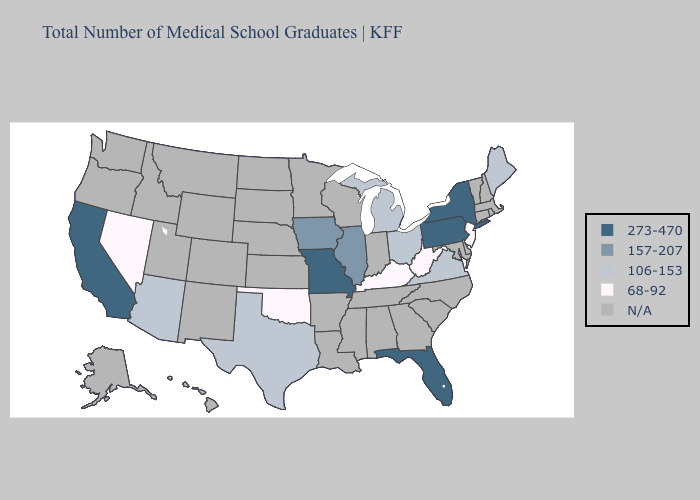What is the value of Florida?
Give a very brief answer. 273-470. Does New York have the highest value in the USA?
Keep it brief. Yes. Does California have the lowest value in the West?
Concise answer only. No. What is the lowest value in the South?
Concise answer only. 68-92. What is the value of North Dakota?
Short answer required. N/A. Among the states that border Nevada , which have the lowest value?
Keep it brief. Arizona. What is the value of Delaware?
Concise answer only. N/A. What is the value of Kansas?
Short answer required. N/A. Does West Virginia have the lowest value in the USA?
Answer briefly. Yes. What is the lowest value in the MidWest?
Answer briefly. 106-153. What is the value of West Virginia?
Concise answer only. 68-92. What is the value of North Dakota?
Keep it brief. N/A. Name the states that have a value in the range 157-207?
Be succinct. Illinois, Iowa. 